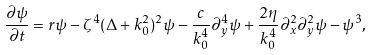<formula> <loc_0><loc_0><loc_500><loc_500>\frac { \partial \psi } { \partial t } = r \psi - \zeta ^ { 4 } ( \Delta + k _ { 0 } ^ { 2 } ) ^ { 2 } \psi - \frac { c } { k _ { 0 } ^ { 4 } } \partial _ { y } ^ { 4 } \psi + \frac { 2 \eta } { k _ { 0 } ^ { 4 } } \partial _ { x } ^ { 2 } \partial _ { y } ^ { 2 } \psi - \psi ^ { 3 } ,</formula> 